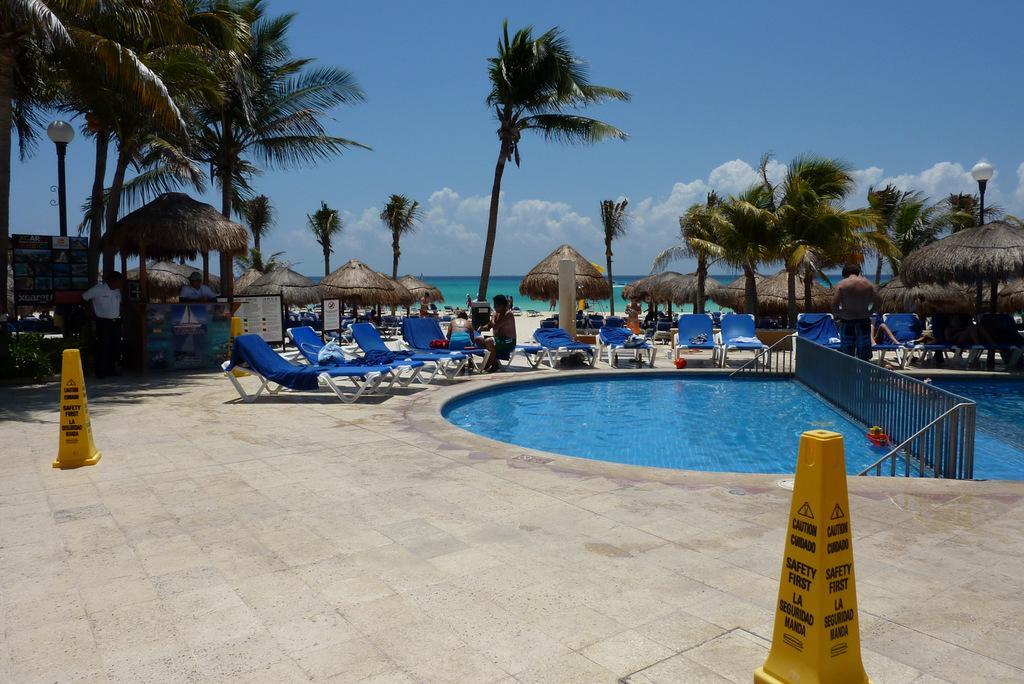Please provide a concise description of this image. In this image, there are a few people, chairs, trees, poles. We can see some water and the ground with some objects. We can also see some sheds and boards. We can also see the sky with clouds. We can see the fence. 